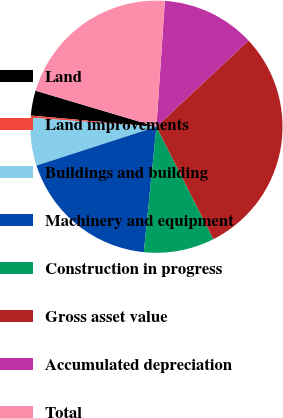<chart> <loc_0><loc_0><loc_500><loc_500><pie_chart><fcel>Land<fcel>Land improvements<fcel>Buildings and building<fcel>Machinery and equipment<fcel>Construction in progress<fcel>Gross asset value<fcel>Accumulated depreciation<fcel>Total<nl><fcel>3.2%<fcel>0.28%<fcel>6.12%<fcel>18.42%<fcel>9.05%<fcel>29.51%<fcel>11.97%<fcel>21.46%<nl></chart> 